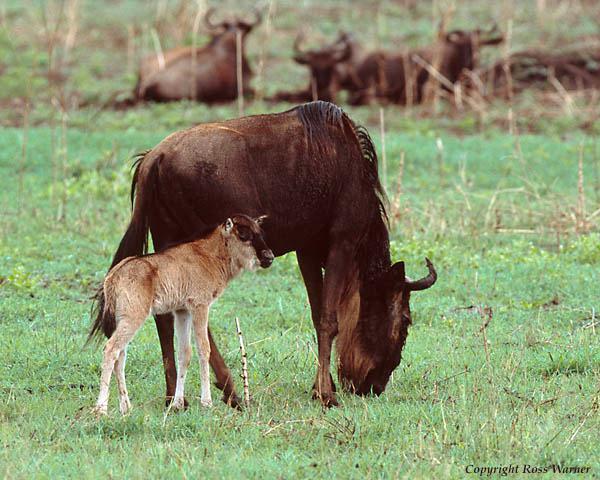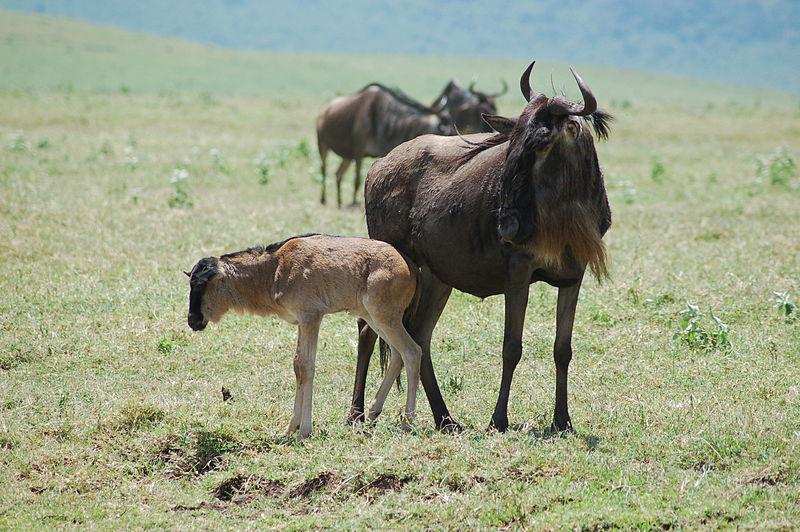The first image is the image on the left, the second image is the image on the right. For the images displayed, is the sentence "An animal is laying bleeding in the image on the right." factually correct? Answer yes or no. No. The first image is the image on the left, the second image is the image on the right. Examine the images to the left and right. Is the description "There is exactly one hyena." accurate? Answer yes or no. No. 